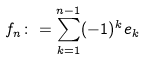<formula> <loc_0><loc_0><loc_500><loc_500>f _ { n } \colon = \sum _ { k = 1 } ^ { n - 1 } ( - 1 ) ^ { k } e _ { k }</formula> 